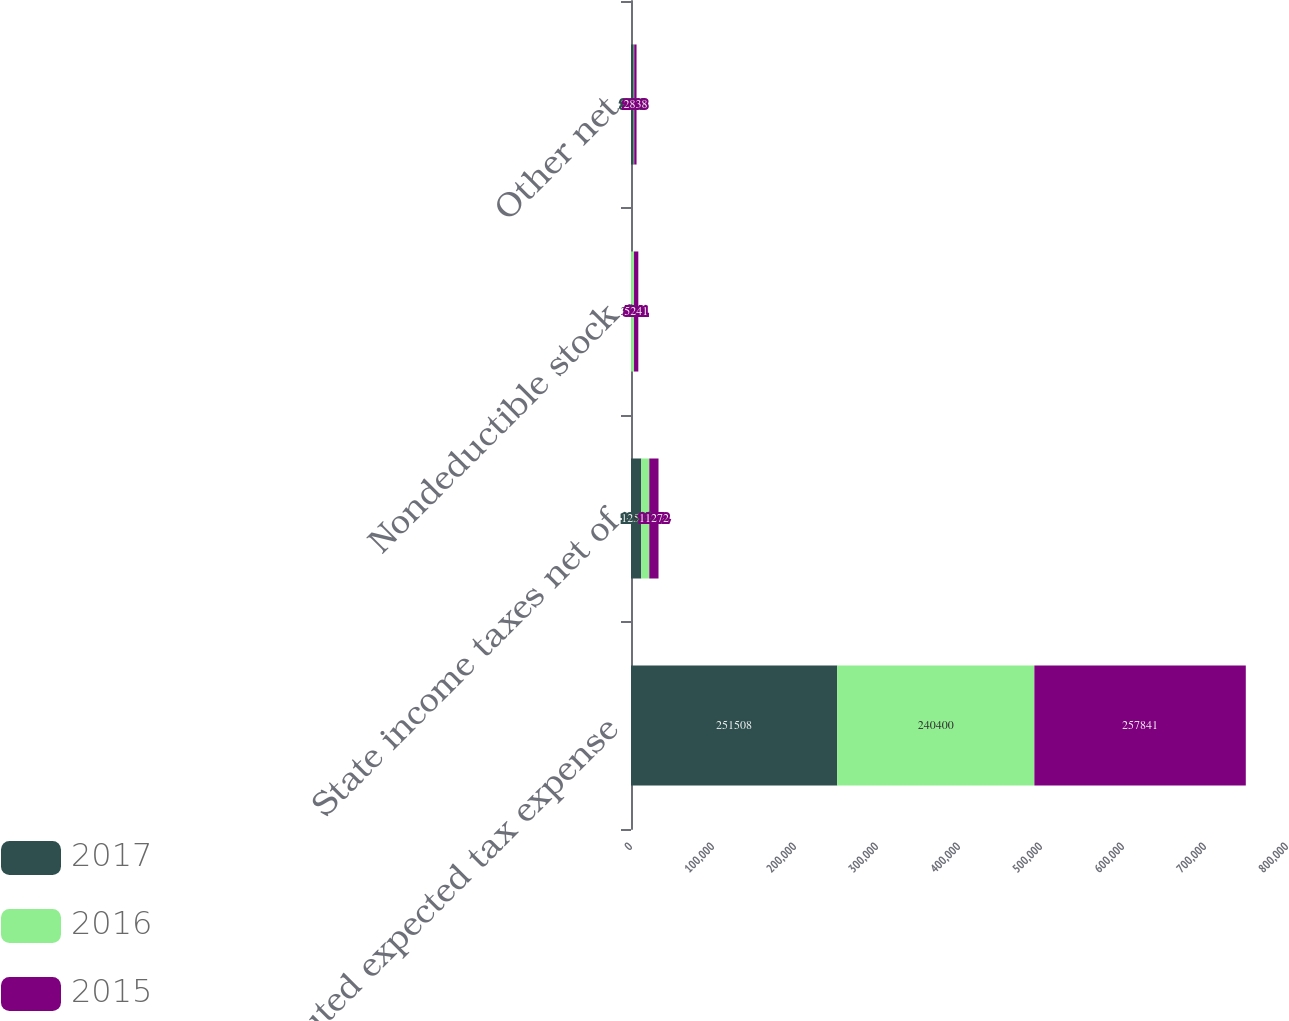Convert chart. <chart><loc_0><loc_0><loc_500><loc_500><stacked_bar_chart><ecel><fcel>Computed expected tax expense<fcel>State income taxes net of<fcel>Nondeductible stock<fcel>Other net<nl><fcel>2017<fcel>251508<fcel>12525<fcel>63<fcel>3384<nl><fcel>2016<fcel>240400<fcel>9759<fcel>3629<fcel>535<nl><fcel>2015<fcel>257841<fcel>11272<fcel>5241<fcel>2838<nl></chart> 